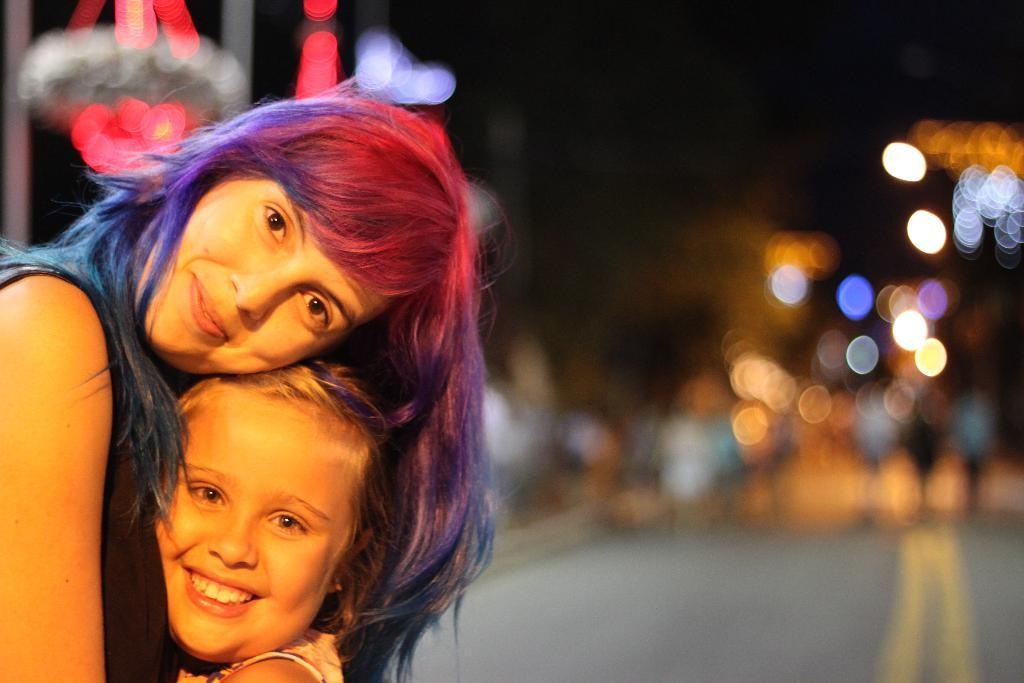How many people are in the image? There are two women in the image. What are the women doing in the image? The women are smiling. What can be seen in the background of the image? There are lights visible in the background of the image. What type of crook is the woman holding in the image? There is no crook present in the image; the women are simply smiling. How does the heat affect the women in the image? The provided facts do not mention heat, so we cannot determine its effect on the women in the image. 